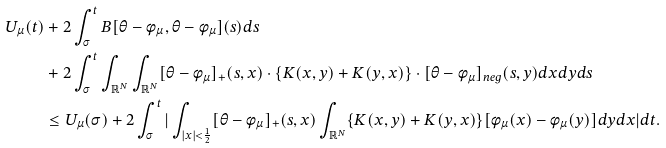Convert formula to latex. <formula><loc_0><loc_0><loc_500><loc_500>U _ { \mu } ( t ) & + 2 \int _ { \sigma } ^ { t } B [ \theta - \phi _ { \mu } , \theta - \phi _ { \mu } ] ( s ) d s \\ & + 2 \int _ { \sigma } ^ { t } \int _ { \mathbb { R } ^ { N } } \int _ { \mathbb { R } ^ { N } } [ \theta - \phi _ { \mu } ] _ { + } ( s , x ) \cdot \{ K ( x , y ) + K ( y , x ) \} \cdot [ \theta - \phi _ { \mu } ] _ { n e g } ( s , y ) d x d y d s \\ & \leq U _ { \mu } ( \sigma ) + 2 \int _ { \sigma } ^ { t } | \int _ { | x | < \frac { 1 } { 2 } } [ \theta - \phi _ { \mu } ] _ { + } ( s , x ) \int _ { \mathbb { R } ^ { N } } \{ K ( x , y ) + K ( y , x ) \} [ \phi _ { \mu } ( x ) - \phi _ { \mu } ( y ) ] d y d x | d t .</formula> 